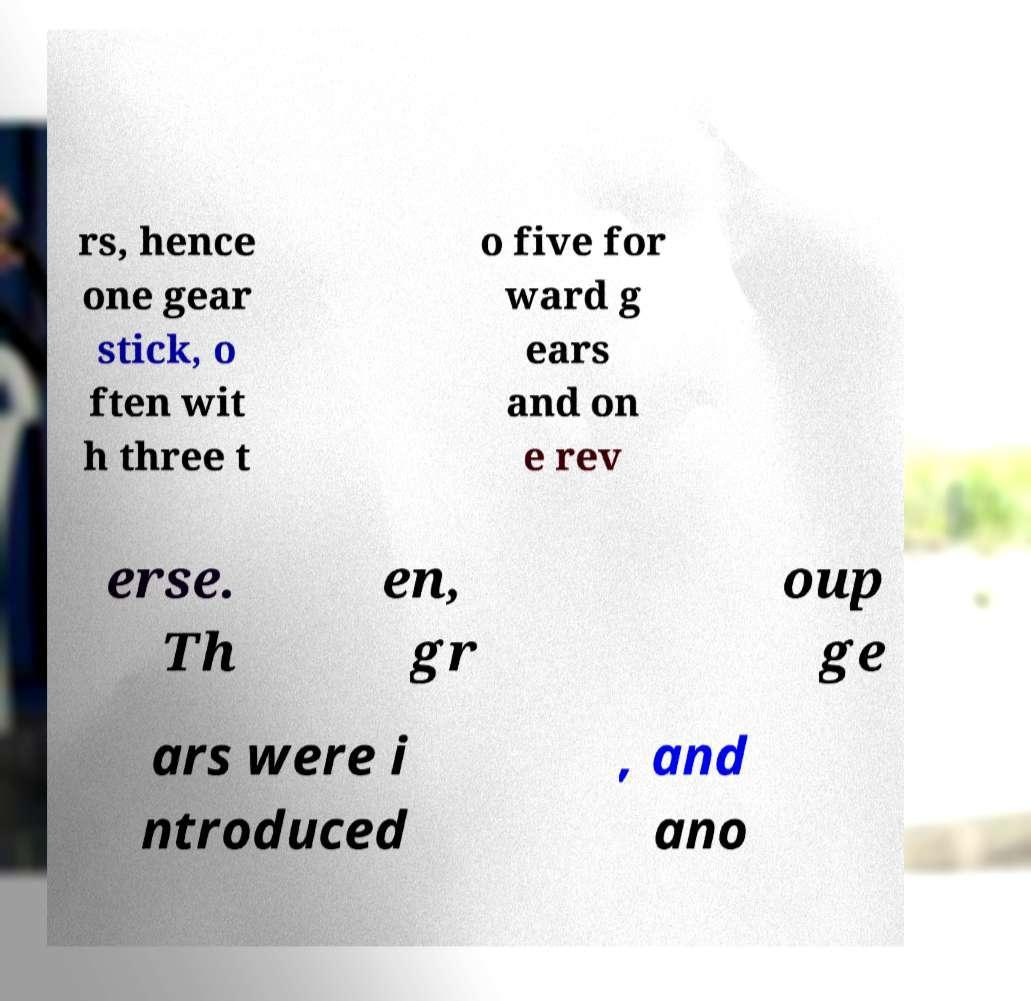There's text embedded in this image that I need extracted. Can you transcribe it verbatim? rs, hence one gear stick, o ften wit h three t o five for ward g ears and on e rev erse. Th en, gr oup ge ars were i ntroduced , and ano 